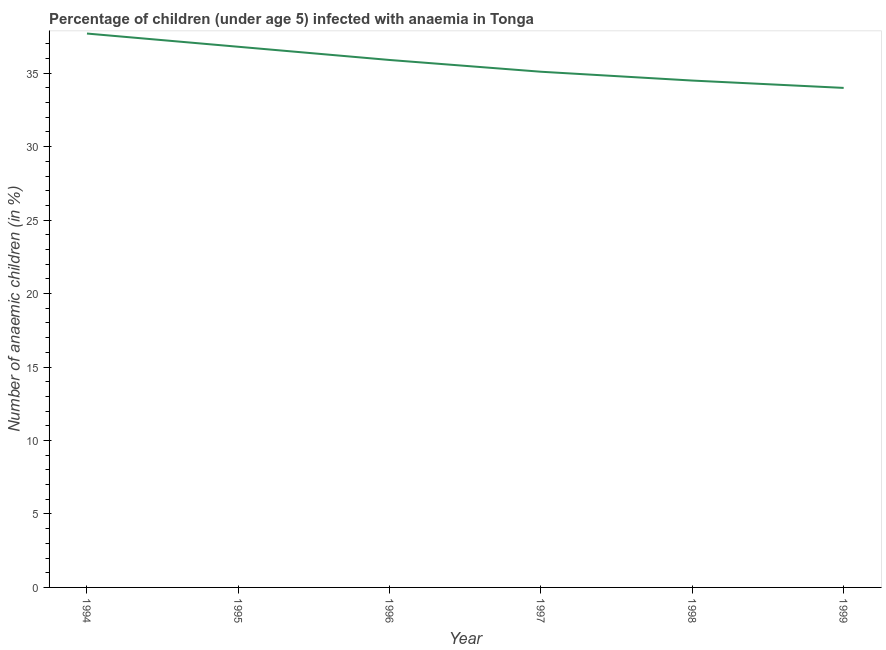What is the number of anaemic children in 1996?
Provide a succinct answer. 35.9. Across all years, what is the maximum number of anaemic children?
Keep it short and to the point. 37.7. Across all years, what is the minimum number of anaemic children?
Make the answer very short. 34. In which year was the number of anaemic children maximum?
Offer a terse response. 1994. In which year was the number of anaemic children minimum?
Make the answer very short. 1999. What is the sum of the number of anaemic children?
Offer a very short reply. 214. What is the difference between the number of anaemic children in 1995 and 1999?
Your answer should be compact. 2.8. What is the average number of anaemic children per year?
Your response must be concise. 35.67. What is the median number of anaemic children?
Your answer should be compact. 35.5. Do a majority of the years between 1995 and 1994 (inclusive) have number of anaemic children greater than 13 %?
Your response must be concise. No. What is the ratio of the number of anaemic children in 1995 to that in 1998?
Your answer should be very brief. 1.07. Is the number of anaemic children in 1994 less than that in 1996?
Ensure brevity in your answer.  No. What is the difference between the highest and the second highest number of anaemic children?
Ensure brevity in your answer.  0.9. What is the difference between the highest and the lowest number of anaemic children?
Provide a succinct answer. 3.7. In how many years, is the number of anaemic children greater than the average number of anaemic children taken over all years?
Your answer should be compact. 3. Does the number of anaemic children monotonically increase over the years?
Ensure brevity in your answer.  No. What is the difference between two consecutive major ticks on the Y-axis?
Keep it short and to the point. 5. Does the graph contain any zero values?
Keep it short and to the point. No. Does the graph contain grids?
Keep it short and to the point. No. What is the title of the graph?
Your answer should be very brief. Percentage of children (under age 5) infected with anaemia in Tonga. What is the label or title of the Y-axis?
Make the answer very short. Number of anaemic children (in %). What is the Number of anaemic children (in %) in 1994?
Your answer should be compact. 37.7. What is the Number of anaemic children (in %) in 1995?
Offer a terse response. 36.8. What is the Number of anaemic children (in %) in 1996?
Provide a succinct answer. 35.9. What is the Number of anaemic children (in %) in 1997?
Ensure brevity in your answer.  35.1. What is the Number of anaemic children (in %) of 1998?
Offer a terse response. 34.5. What is the Number of anaemic children (in %) in 1999?
Provide a succinct answer. 34. What is the difference between the Number of anaemic children (in %) in 1994 and 1998?
Keep it short and to the point. 3.2. What is the difference between the Number of anaemic children (in %) in 1995 and 1996?
Offer a terse response. 0.9. What is the difference between the Number of anaemic children (in %) in 1995 and 1997?
Make the answer very short. 1.7. What is the difference between the Number of anaemic children (in %) in 1995 and 1999?
Provide a succinct answer. 2.8. What is the difference between the Number of anaemic children (in %) in 1998 and 1999?
Make the answer very short. 0.5. What is the ratio of the Number of anaemic children (in %) in 1994 to that in 1995?
Make the answer very short. 1.02. What is the ratio of the Number of anaemic children (in %) in 1994 to that in 1997?
Your response must be concise. 1.07. What is the ratio of the Number of anaemic children (in %) in 1994 to that in 1998?
Keep it short and to the point. 1.09. What is the ratio of the Number of anaemic children (in %) in 1994 to that in 1999?
Keep it short and to the point. 1.11. What is the ratio of the Number of anaemic children (in %) in 1995 to that in 1996?
Your response must be concise. 1.02. What is the ratio of the Number of anaemic children (in %) in 1995 to that in 1997?
Give a very brief answer. 1.05. What is the ratio of the Number of anaemic children (in %) in 1995 to that in 1998?
Offer a terse response. 1.07. What is the ratio of the Number of anaemic children (in %) in 1995 to that in 1999?
Provide a short and direct response. 1.08. What is the ratio of the Number of anaemic children (in %) in 1996 to that in 1997?
Offer a very short reply. 1.02. What is the ratio of the Number of anaemic children (in %) in 1996 to that in 1998?
Ensure brevity in your answer.  1.04. What is the ratio of the Number of anaemic children (in %) in 1996 to that in 1999?
Give a very brief answer. 1.06. What is the ratio of the Number of anaemic children (in %) in 1997 to that in 1998?
Your answer should be compact. 1.02. What is the ratio of the Number of anaemic children (in %) in 1997 to that in 1999?
Your answer should be compact. 1.03. 